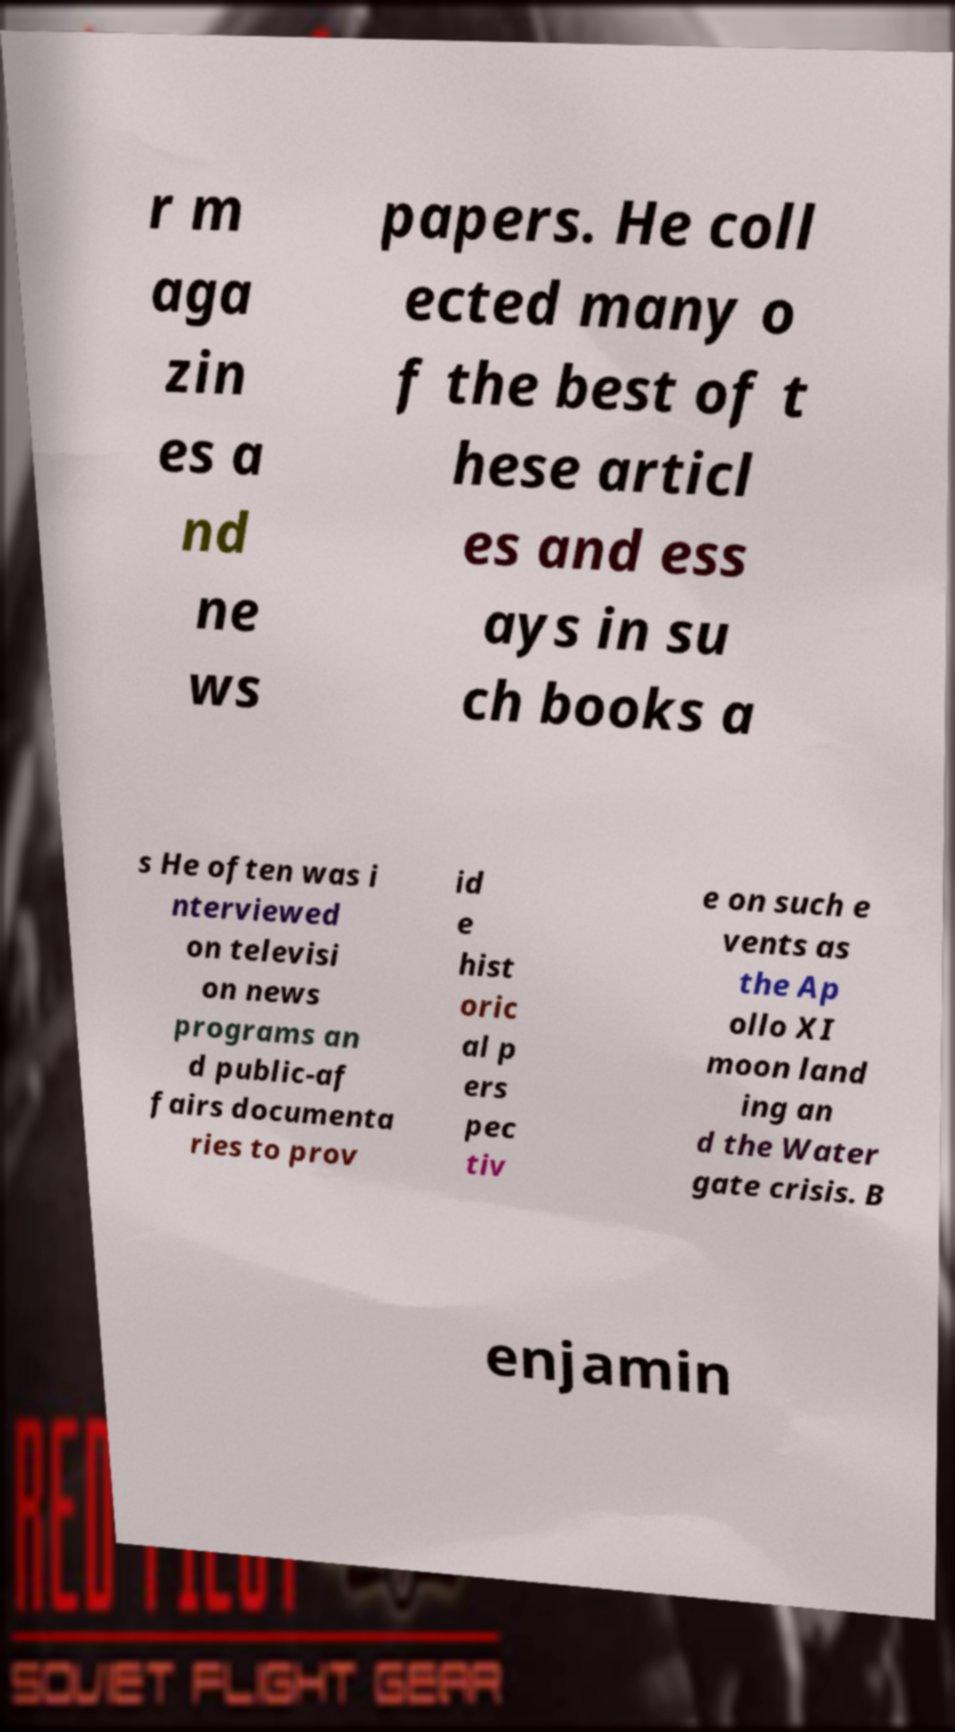Can you accurately transcribe the text from the provided image for me? r m aga zin es a nd ne ws papers. He coll ected many o f the best of t hese articl es and ess ays in su ch books a s He often was i nterviewed on televisi on news programs an d public-af fairs documenta ries to prov id e hist oric al p ers pec tiv e on such e vents as the Ap ollo XI moon land ing an d the Water gate crisis. B enjamin 